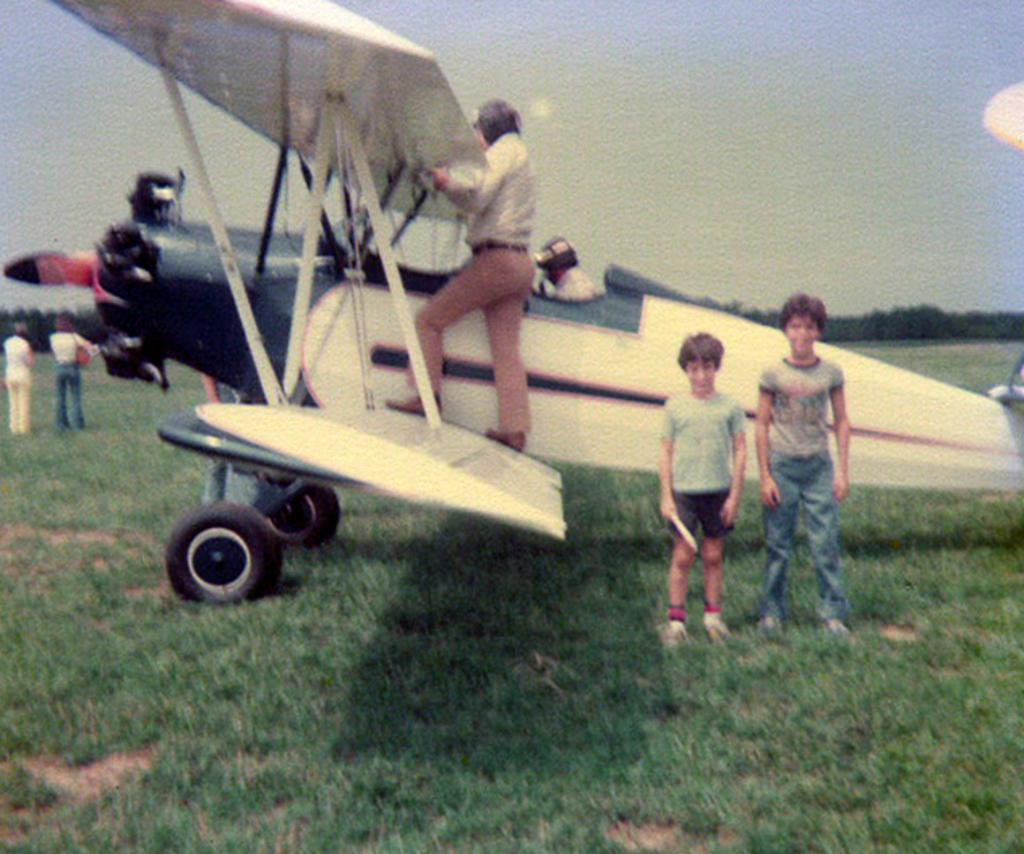What is the main subject of the image? The main subject of the image is an aircraft. What colors can be seen on the aircraft? The aircraft is white, black, and red in color. Can you describe the people visible in the image? There are people visible in the image, but their specific actions or characteristics are not mentioned in the facts. What type of vegetation is present in the image? There is green grass in the image. What can be seen in the background of the image? There are trees and the sky visible in the background of the image. Where is the nearest library to the location of the image? The facts provided do not mention any information about a library or its location, so it cannot be determined from the image. What time of day is it in the image? The facts provided do not mention any information about the time of day, so it cannot be determined from the image. 